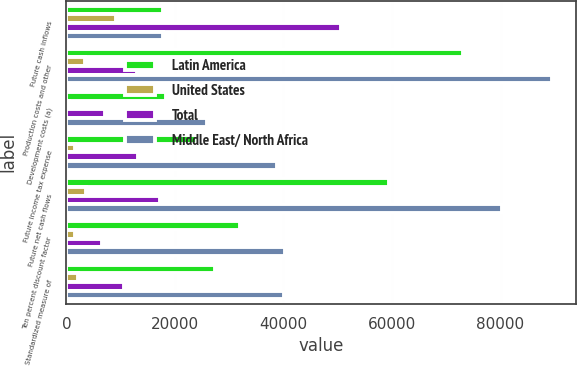Convert chart to OTSL. <chart><loc_0><loc_0><loc_500><loc_500><stacked_bar_chart><ecel><fcel>Future cash inflows<fcel>Production costs and other<fcel>Development costs (a)<fcel>Future income tax expense<fcel>Future net cash flows<fcel>Ten percent discount factor<fcel>Standardized measure of<nl><fcel>Latin America<fcel>17786.5<fcel>73092<fcel>18365<fcel>24014<fcel>59494<fcel>32035<fcel>27459<nl><fcel>United States<fcel>9076<fcel>3375<fcel>477<fcel>1571<fcel>3653<fcel>1557<fcel>2096<nl><fcel>Total<fcel>50517<fcel>13043<fcel>7084<fcel>13182<fcel>17208<fcel>6597<fcel>10611<nl><fcel>Middle East/ North Africa<fcel>17786.5<fcel>89510<fcel>25926<fcel>38767<fcel>80355<fcel>40189<fcel>40166<nl></chart> 